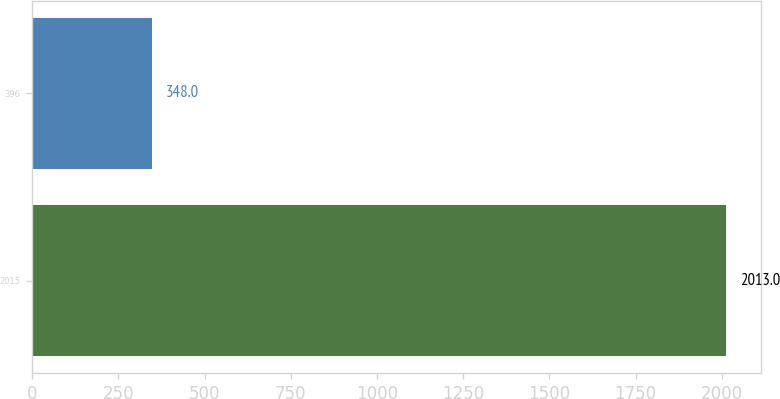Convert chart to OTSL. <chart><loc_0><loc_0><loc_500><loc_500><bar_chart><fcel>2015<fcel>396<nl><fcel>2013<fcel>348<nl></chart> 